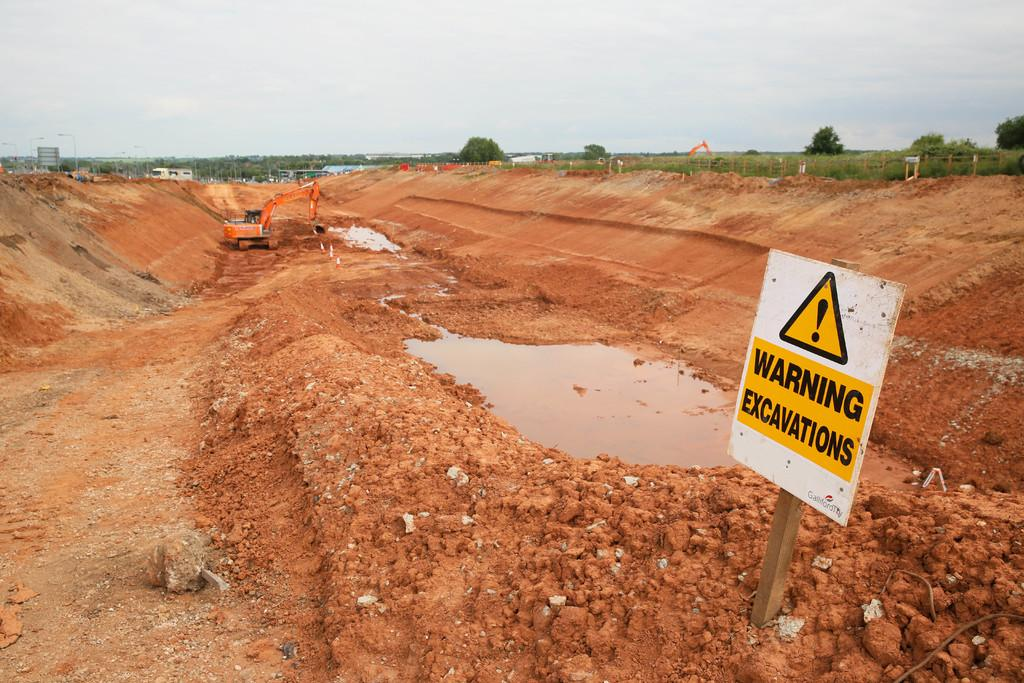What is the primary element visible in the image? There is a lot of soil in the image. What is located in the foreground of the image? There is a caution board in the foreground. What type of machinery can be seen in the image? There is a crane between the soil surface. What can be seen in the background of the image? There are trees in the background of the image. What type of peace symbol can be seen in the image? There is no peace symbol present in the image. What type of plants are growing in the soil in the image? The provided facts do not mention any plants growing in the soil; only trees are mentioned in the background. 